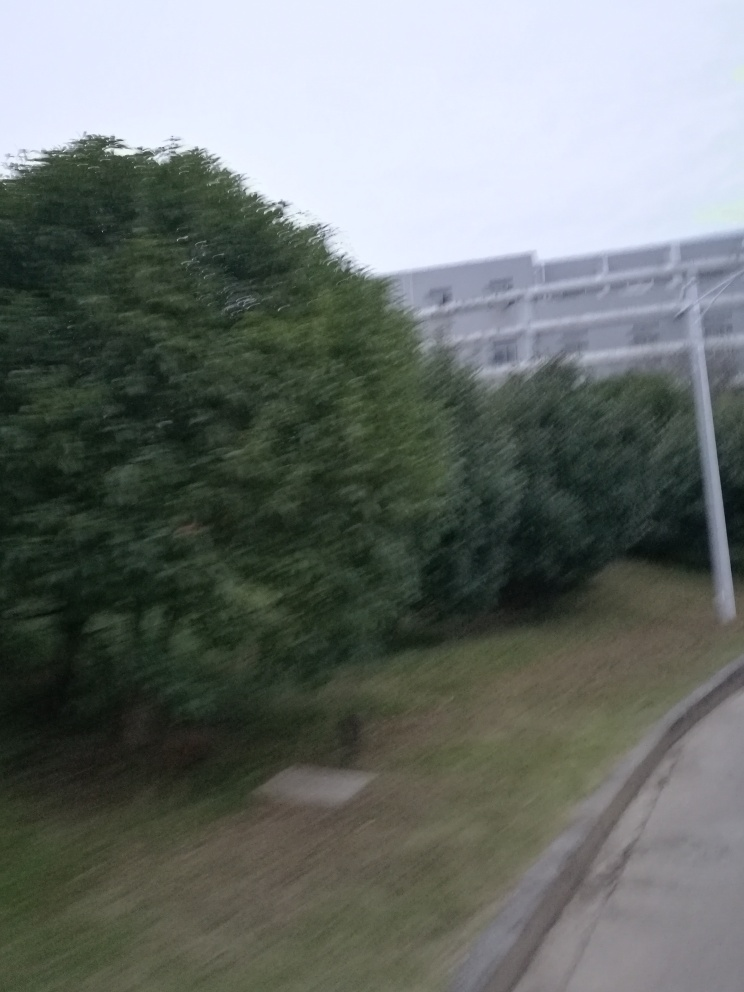What could be the reasons for the blurriness of this image? The blurriness in this image could be attributed to several factors such as shaky hands while taking the photo, a moving subject or camera, a low shutter speed which was not fast enough to freeze the moment, or a camera that is not focused properly. It also looks like the lighting conditions might be dim, which can contribute to poor image sharpness if the camera's sensitivity (ISO) wasn't adjusted appropriately. 